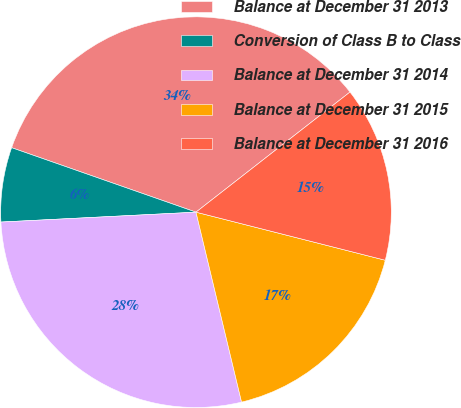Convert chart to OTSL. <chart><loc_0><loc_0><loc_500><loc_500><pie_chart><fcel>Balance at December 31 2013<fcel>Conversion of Class B to Class<fcel>Balance at December 31 2014<fcel>Balance at December 31 2015<fcel>Balance at December 31 2016<nl><fcel>34.1%<fcel>6.16%<fcel>27.94%<fcel>17.29%<fcel>14.5%<nl></chart> 